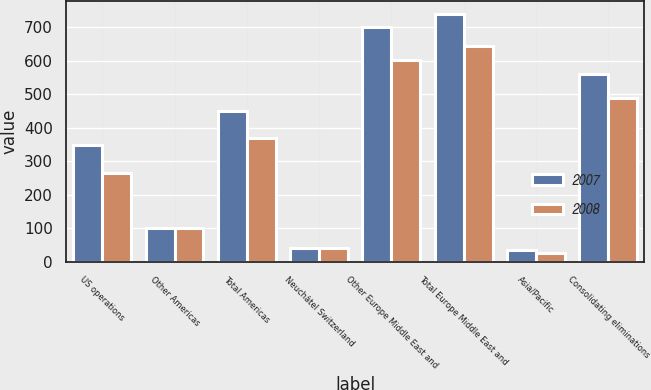Convert chart to OTSL. <chart><loc_0><loc_0><loc_500><loc_500><stacked_bar_chart><ecel><fcel>US operations<fcel>Other Americas<fcel>Total Americas<fcel>Neuchâtel Switzerland<fcel>Other Europe Middle East and<fcel>Total Europe Middle East and<fcel>Asia/Pacific<fcel>Consolidating eliminations<nl><fcel>2007<fcel>349.3<fcel>102.1<fcel>451.4<fcel>40<fcel>700.5<fcel>740.5<fcel>36.4<fcel>560.9<nl><fcel>2008<fcel>266.4<fcel>102.1<fcel>368.5<fcel>40.9<fcel>603.9<fcel>644.8<fcel>25.2<fcel>490.5<nl></chart> 